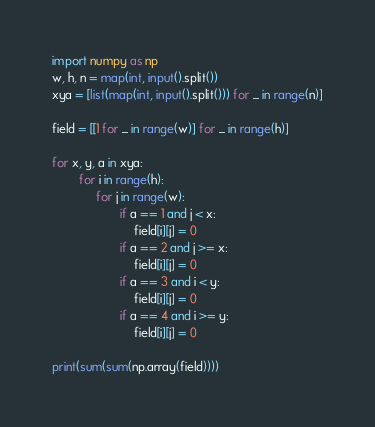Convert code to text. <code><loc_0><loc_0><loc_500><loc_500><_Python_>import numpy as np
w, h, n = map(int, input().split())
xya = [list(map(int, input().split())) for _ in range(n)]

field = [[1 for _ in range(w)] for _ in range(h)]

for x, y, a in xya:
        for i in range(h):
             for j in range(w):
                    if a == 1 and j < x:
                        field[i][j] = 0
                    if a == 2 and j >= x:
                        field[i][j] = 0
                    if a == 3 and i < y:
                        field[i][j] = 0
                    if a == 4 and i >= y:
                        field[i][j] = 0

print(sum(sum(np.array(field))))</code> 